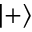<formula> <loc_0><loc_0><loc_500><loc_500>| + \rangle</formula> 